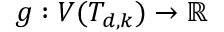<formula> <loc_0><loc_0><loc_500><loc_500>g \colon V ( T _ { d , k } ) \rightarrow \mathbb { R }</formula> 